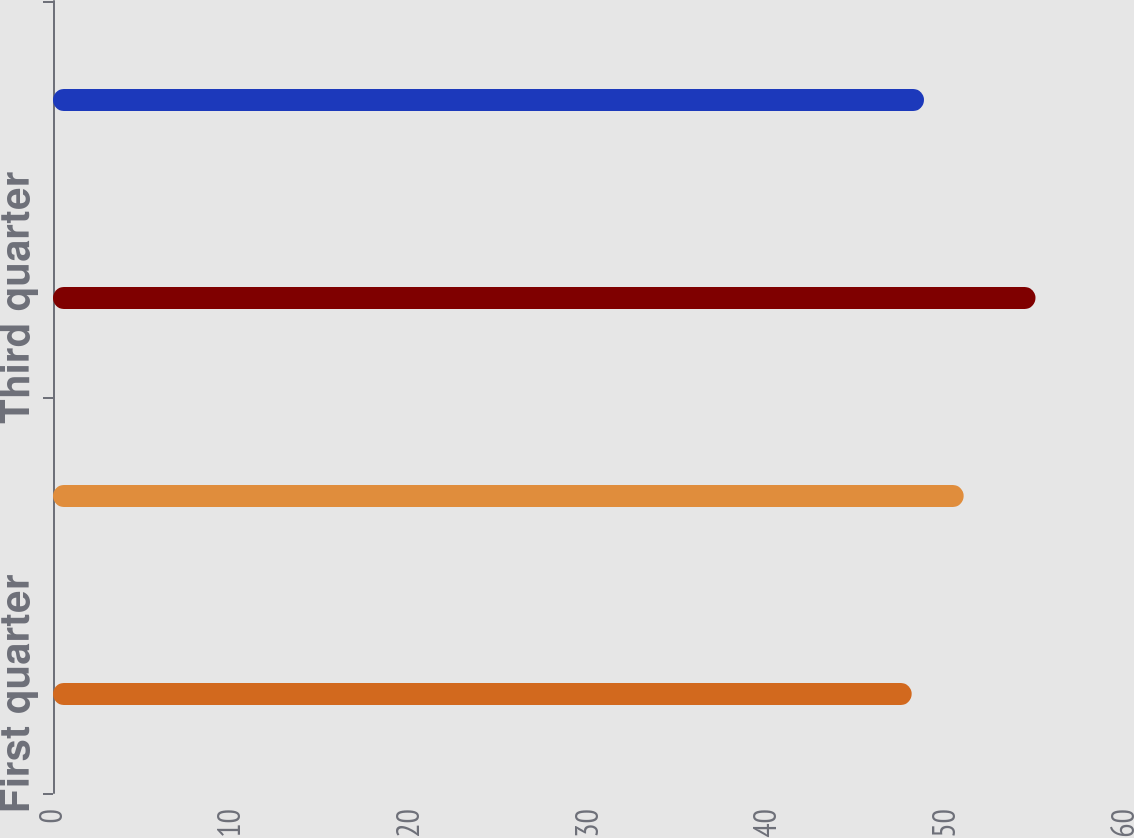Convert chart to OTSL. <chart><loc_0><loc_0><loc_500><loc_500><bar_chart><fcel>First quarter<fcel>Second quarter<fcel>Third quarter<fcel>Fourth quarter<nl><fcel>48.06<fcel>50.97<fcel>54.99<fcel>48.75<nl></chart> 